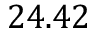<formula> <loc_0><loc_0><loc_500><loc_500>2 4 . 4 2</formula> 